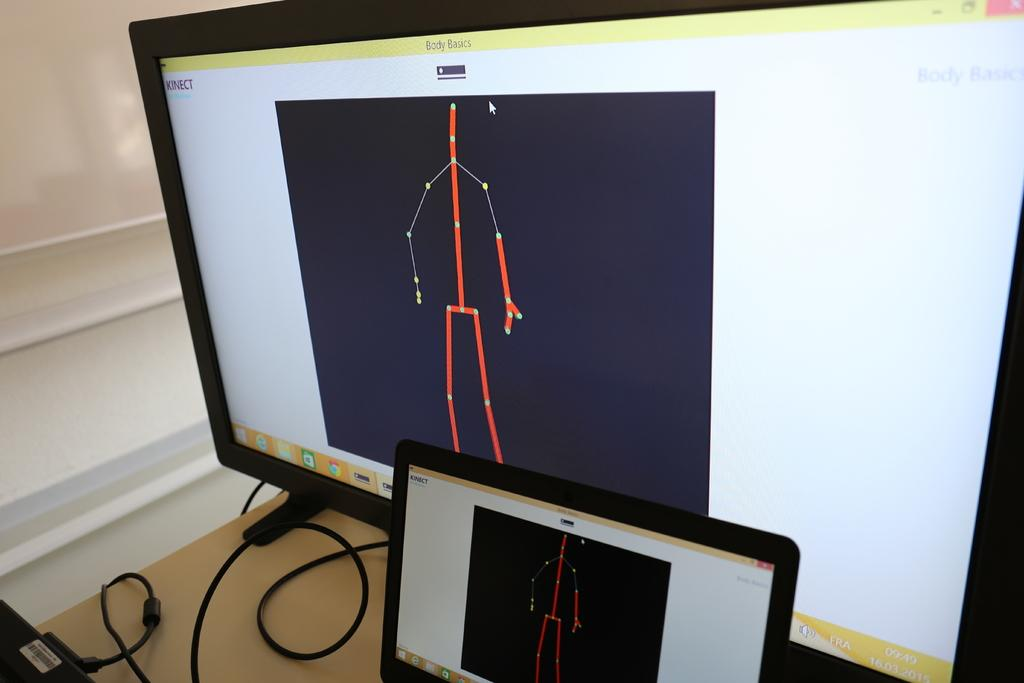<image>
Render a clear and concise summary of the photo. A computer is open to a program called Body Basics. 